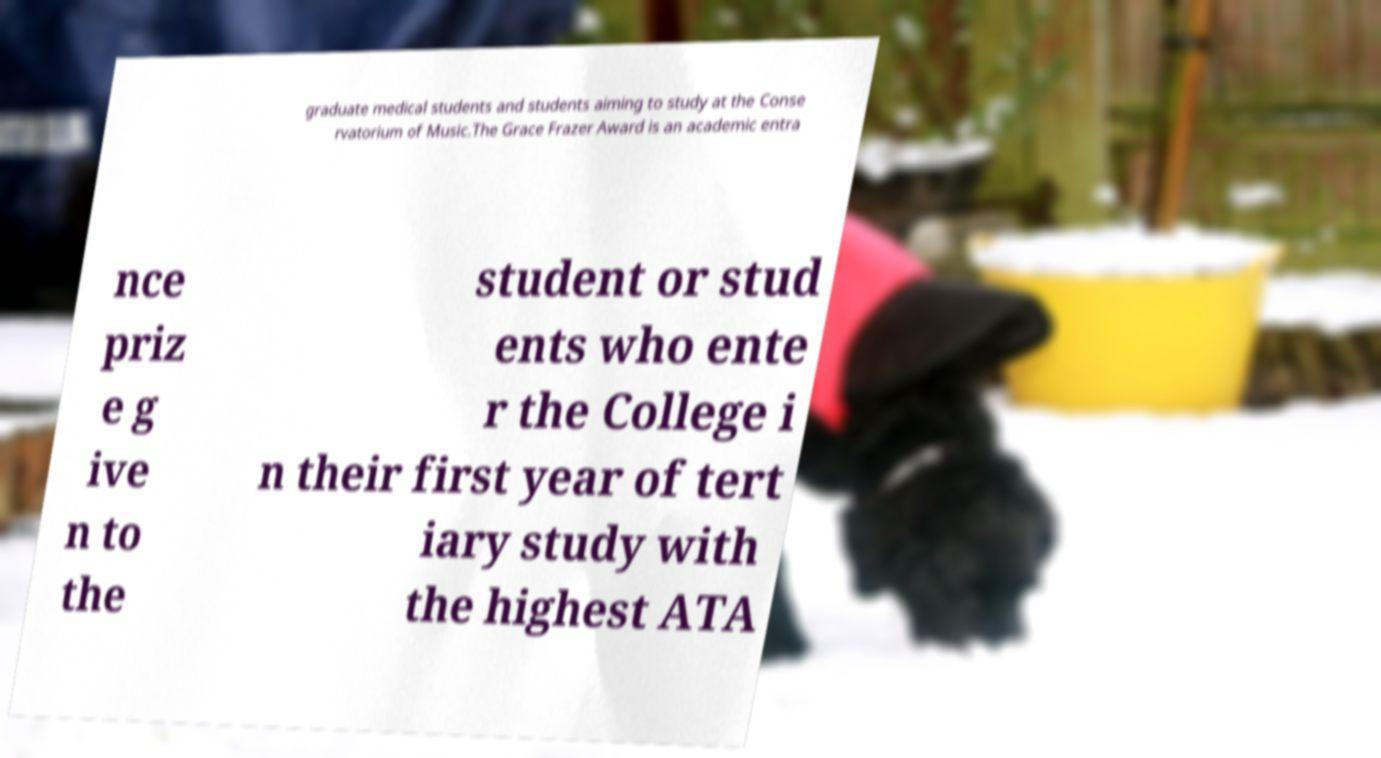Can you read and provide the text displayed in the image?This photo seems to have some interesting text. Can you extract and type it out for me? graduate medical students and students aiming to study at the Conse rvatorium of Music.The Grace Frazer Award is an academic entra nce priz e g ive n to the student or stud ents who ente r the College i n their first year of tert iary study with the highest ATA 